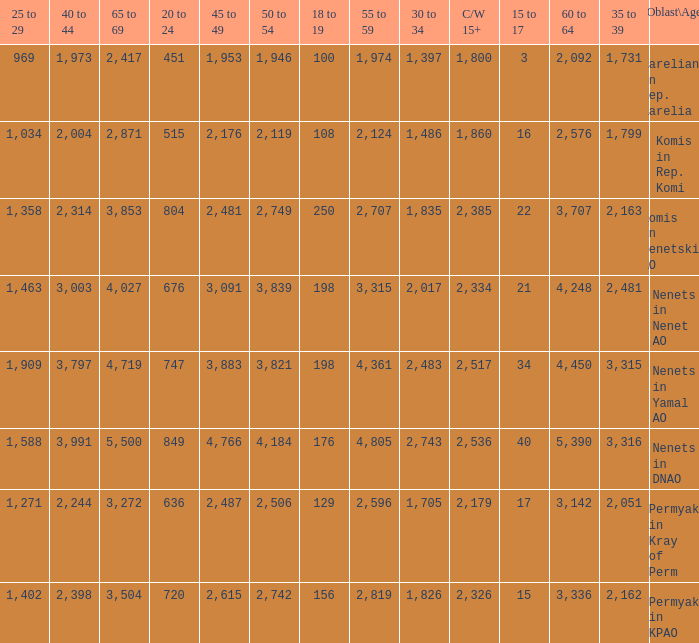What is the mean 55 to 59 when the C/W 15+ is greater than 2,385, and the 30 to 34 is 2,483, and the 35 to 39 is greater than 3,315? None. 